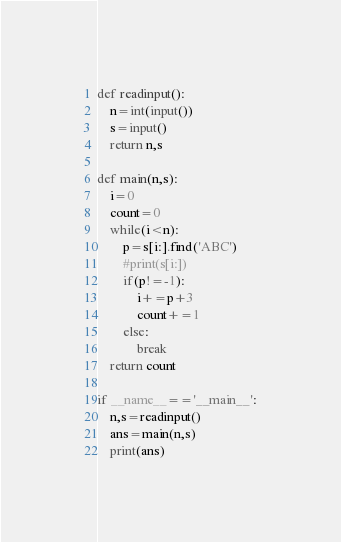<code> <loc_0><loc_0><loc_500><loc_500><_Python_>def readinput():
    n=int(input())
    s=input()
    return n,s

def main(n,s):
    i=0
    count=0
    while(i<n):
        p=s[i:].find('ABC')
        #print(s[i:])
        if(p!=-1):
            i+=p+3
            count+=1
        else:
            break
    return count

if __name__=='__main__':
    n,s=readinput()
    ans=main(n,s)
    print(ans)


</code> 